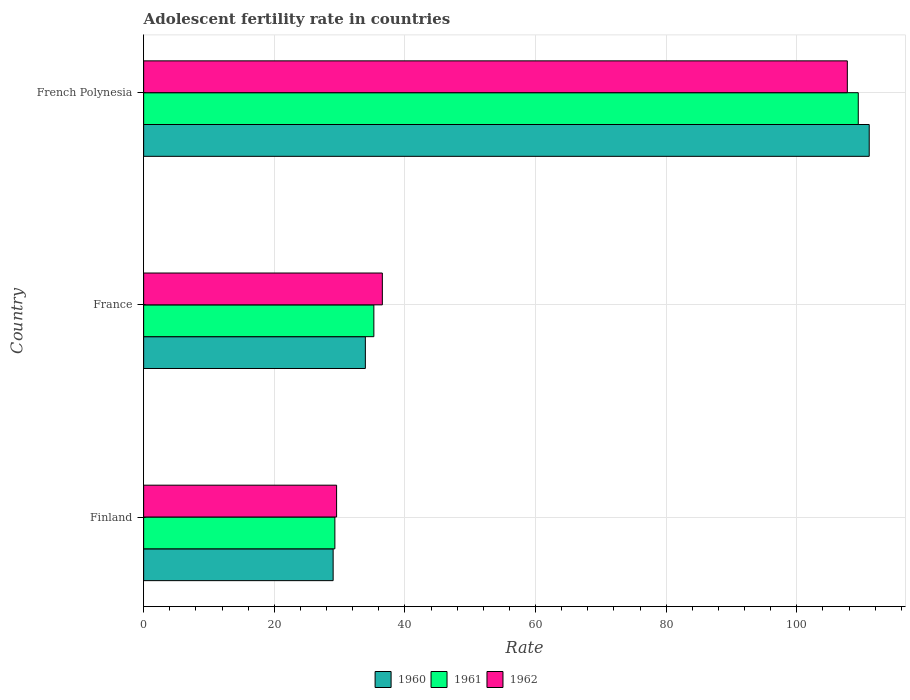How many different coloured bars are there?
Make the answer very short. 3. How many groups of bars are there?
Provide a short and direct response. 3. Are the number of bars per tick equal to the number of legend labels?
Ensure brevity in your answer.  Yes. Are the number of bars on each tick of the Y-axis equal?
Make the answer very short. Yes. How many bars are there on the 3rd tick from the top?
Offer a terse response. 3. How many bars are there on the 3rd tick from the bottom?
Offer a very short reply. 3. What is the label of the 1st group of bars from the top?
Provide a succinct answer. French Polynesia. What is the adolescent fertility rate in 1962 in French Polynesia?
Keep it short and to the point. 107.74. Across all countries, what is the maximum adolescent fertility rate in 1962?
Ensure brevity in your answer.  107.74. Across all countries, what is the minimum adolescent fertility rate in 1960?
Make the answer very short. 29.01. In which country was the adolescent fertility rate in 1961 maximum?
Provide a succinct answer. French Polynesia. In which country was the adolescent fertility rate in 1960 minimum?
Keep it short and to the point. Finland. What is the total adolescent fertility rate in 1961 in the graph?
Your answer should be very brief. 173.94. What is the difference between the adolescent fertility rate in 1961 in Finland and that in French Polynesia?
Offer a terse response. -80.14. What is the difference between the adolescent fertility rate in 1962 in French Polynesia and the adolescent fertility rate in 1961 in Finland?
Keep it short and to the point. 78.46. What is the average adolescent fertility rate in 1961 per country?
Provide a succinct answer. 57.98. What is the difference between the adolescent fertility rate in 1960 and adolescent fertility rate in 1961 in Finland?
Your answer should be compact. -0.26. What is the ratio of the adolescent fertility rate in 1961 in Finland to that in French Polynesia?
Make the answer very short. 0.27. Is the adolescent fertility rate in 1961 in Finland less than that in French Polynesia?
Give a very brief answer. Yes. Is the difference between the adolescent fertility rate in 1960 in Finland and France greater than the difference between the adolescent fertility rate in 1961 in Finland and France?
Keep it short and to the point. Yes. What is the difference between the highest and the second highest adolescent fertility rate in 1961?
Your answer should be very brief. 74.17. What is the difference between the highest and the lowest adolescent fertility rate in 1960?
Your answer should be compact. 82.08. How many bars are there?
Give a very brief answer. 9. Are all the bars in the graph horizontal?
Give a very brief answer. Yes. How many countries are there in the graph?
Keep it short and to the point. 3. Are the values on the major ticks of X-axis written in scientific E-notation?
Offer a terse response. No. Does the graph contain grids?
Give a very brief answer. Yes. Where does the legend appear in the graph?
Provide a succinct answer. Bottom center. How are the legend labels stacked?
Your answer should be compact. Horizontal. What is the title of the graph?
Ensure brevity in your answer.  Adolescent fertility rate in countries. What is the label or title of the X-axis?
Your answer should be compact. Rate. What is the label or title of the Y-axis?
Your answer should be very brief. Country. What is the Rate of 1960 in Finland?
Your response must be concise. 29.01. What is the Rate of 1961 in Finland?
Make the answer very short. 29.28. What is the Rate in 1962 in Finland?
Keep it short and to the point. 29.54. What is the Rate in 1960 in France?
Ensure brevity in your answer.  33.95. What is the Rate in 1961 in France?
Your answer should be very brief. 35.25. What is the Rate in 1962 in France?
Offer a very short reply. 36.55. What is the Rate of 1960 in French Polynesia?
Keep it short and to the point. 111.09. What is the Rate of 1961 in French Polynesia?
Ensure brevity in your answer.  109.41. What is the Rate of 1962 in French Polynesia?
Provide a succinct answer. 107.74. Across all countries, what is the maximum Rate of 1960?
Your response must be concise. 111.09. Across all countries, what is the maximum Rate in 1961?
Provide a short and direct response. 109.41. Across all countries, what is the maximum Rate in 1962?
Your response must be concise. 107.74. Across all countries, what is the minimum Rate of 1960?
Your answer should be very brief. 29.01. Across all countries, what is the minimum Rate of 1961?
Keep it short and to the point. 29.28. Across all countries, what is the minimum Rate in 1962?
Your answer should be very brief. 29.54. What is the total Rate in 1960 in the graph?
Your response must be concise. 174.05. What is the total Rate of 1961 in the graph?
Ensure brevity in your answer.  173.94. What is the total Rate in 1962 in the graph?
Ensure brevity in your answer.  173.83. What is the difference between the Rate of 1960 in Finland and that in France?
Offer a very short reply. -4.93. What is the difference between the Rate of 1961 in Finland and that in France?
Offer a terse response. -5.97. What is the difference between the Rate in 1962 in Finland and that in France?
Offer a very short reply. -7. What is the difference between the Rate of 1960 in Finland and that in French Polynesia?
Provide a short and direct response. -82.08. What is the difference between the Rate of 1961 in Finland and that in French Polynesia?
Provide a succinct answer. -80.14. What is the difference between the Rate of 1962 in Finland and that in French Polynesia?
Offer a terse response. -78.2. What is the difference between the Rate of 1960 in France and that in French Polynesia?
Give a very brief answer. -77.14. What is the difference between the Rate of 1961 in France and that in French Polynesia?
Offer a terse response. -74.17. What is the difference between the Rate in 1962 in France and that in French Polynesia?
Your answer should be very brief. -71.19. What is the difference between the Rate of 1960 in Finland and the Rate of 1961 in France?
Provide a succinct answer. -6.23. What is the difference between the Rate of 1960 in Finland and the Rate of 1962 in France?
Offer a terse response. -7.53. What is the difference between the Rate of 1961 in Finland and the Rate of 1962 in France?
Make the answer very short. -7.27. What is the difference between the Rate in 1960 in Finland and the Rate in 1961 in French Polynesia?
Your answer should be very brief. -80.4. What is the difference between the Rate of 1960 in Finland and the Rate of 1962 in French Polynesia?
Your answer should be compact. -78.72. What is the difference between the Rate of 1961 in Finland and the Rate of 1962 in French Polynesia?
Make the answer very short. -78.46. What is the difference between the Rate in 1960 in France and the Rate in 1961 in French Polynesia?
Offer a very short reply. -75.47. What is the difference between the Rate of 1960 in France and the Rate of 1962 in French Polynesia?
Make the answer very short. -73.79. What is the difference between the Rate in 1961 in France and the Rate in 1962 in French Polynesia?
Ensure brevity in your answer.  -72.49. What is the average Rate in 1960 per country?
Provide a short and direct response. 58.02. What is the average Rate in 1961 per country?
Your answer should be compact. 57.98. What is the average Rate in 1962 per country?
Provide a succinct answer. 57.94. What is the difference between the Rate in 1960 and Rate in 1961 in Finland?
Your answer should be compact. -0.26. What is the difference between the Rate of 1960 and Rate of 1962 in Finland?
Offer a terse response. -0.53. What is the difference between the Rate in 1961 and Rate in 1962 in Finland?
Your response must be concise. -0.26. What is the difference between the Rate of 1960 and Rate of 1961 in France?
Provide a short and direct response. -1.3. What is the difference between the Rate of 1960 and Rate of 1962 in France?
Offer a very short reply. -2.6. What is the difference between the Rate of 1961 and Rate of 1962 in France?
Ensure brevity in your answer.  -1.3. What is the difference between the Rate of 1960 and Rate of 1961 in French Polynesia?
Your response must be concise. 1.68. What is the difference between the Rate in 1960 and Rate in 1962 in French Polynesia?
Provide a short and direct response. 3.35. What is the difference between the Rate in 1961 and Rate in 1962 in French Polynesia?
Provide a short and direct response. 1.68. What is the ratio of the Rate of 1960 in Finland to that in France?
Offer a terse response. 0.85. What is the ratio of the Rate of 1961 in Finland to that in France?
Offer a terse response. 0.83. What is the ratio of the Rate in 1962 in Finland to that in France?
Make the answer very short. 0.81. What is the ratio of the Rate in 1960 in Finland to that in French Polynesia?
Offer a very short reply. 0.26. What is the ratio of the Rate of 1961 in Finland to that in French Polynesia?
Ensure brevity in your answer.  0.27. What is the ratio of the Rate in 1962 in Finland to that in French Polynesia?
Offer a terse response. 0.27. What is the ratio of the Rate in 1960 in France to that in French Polynesia?
Your answer should be very brief. 0.31. What is the ratio of the Rate in 1961 in France to that in French Polynesia?
Ensure brevity in your answer.  0.32. What is the ratio of the Rate of 1962 in France to that in French Polynesia?
Keep it short and to the point. 0.34. What is the difference between the highest and the second highest Rate in 1960?
Make the answer very short. 77.14. What is the difference between the highest and the second highest Rate of 1961?
Offer a terse response. 74.17. What is the difference between the highest and the second highest Rate in 1962?
Offer a terse response. 71.19. What is the difference between the highest and the lowest Rate of 1960?
Offer a very short reply. 82.08. What is the difference between the highest and the lowest Rate of 1961?
Offer a terse response. 80.14. What is the difference between the highest and the lowest Rate in 1962?
Offer a very short reply. 78.2. 